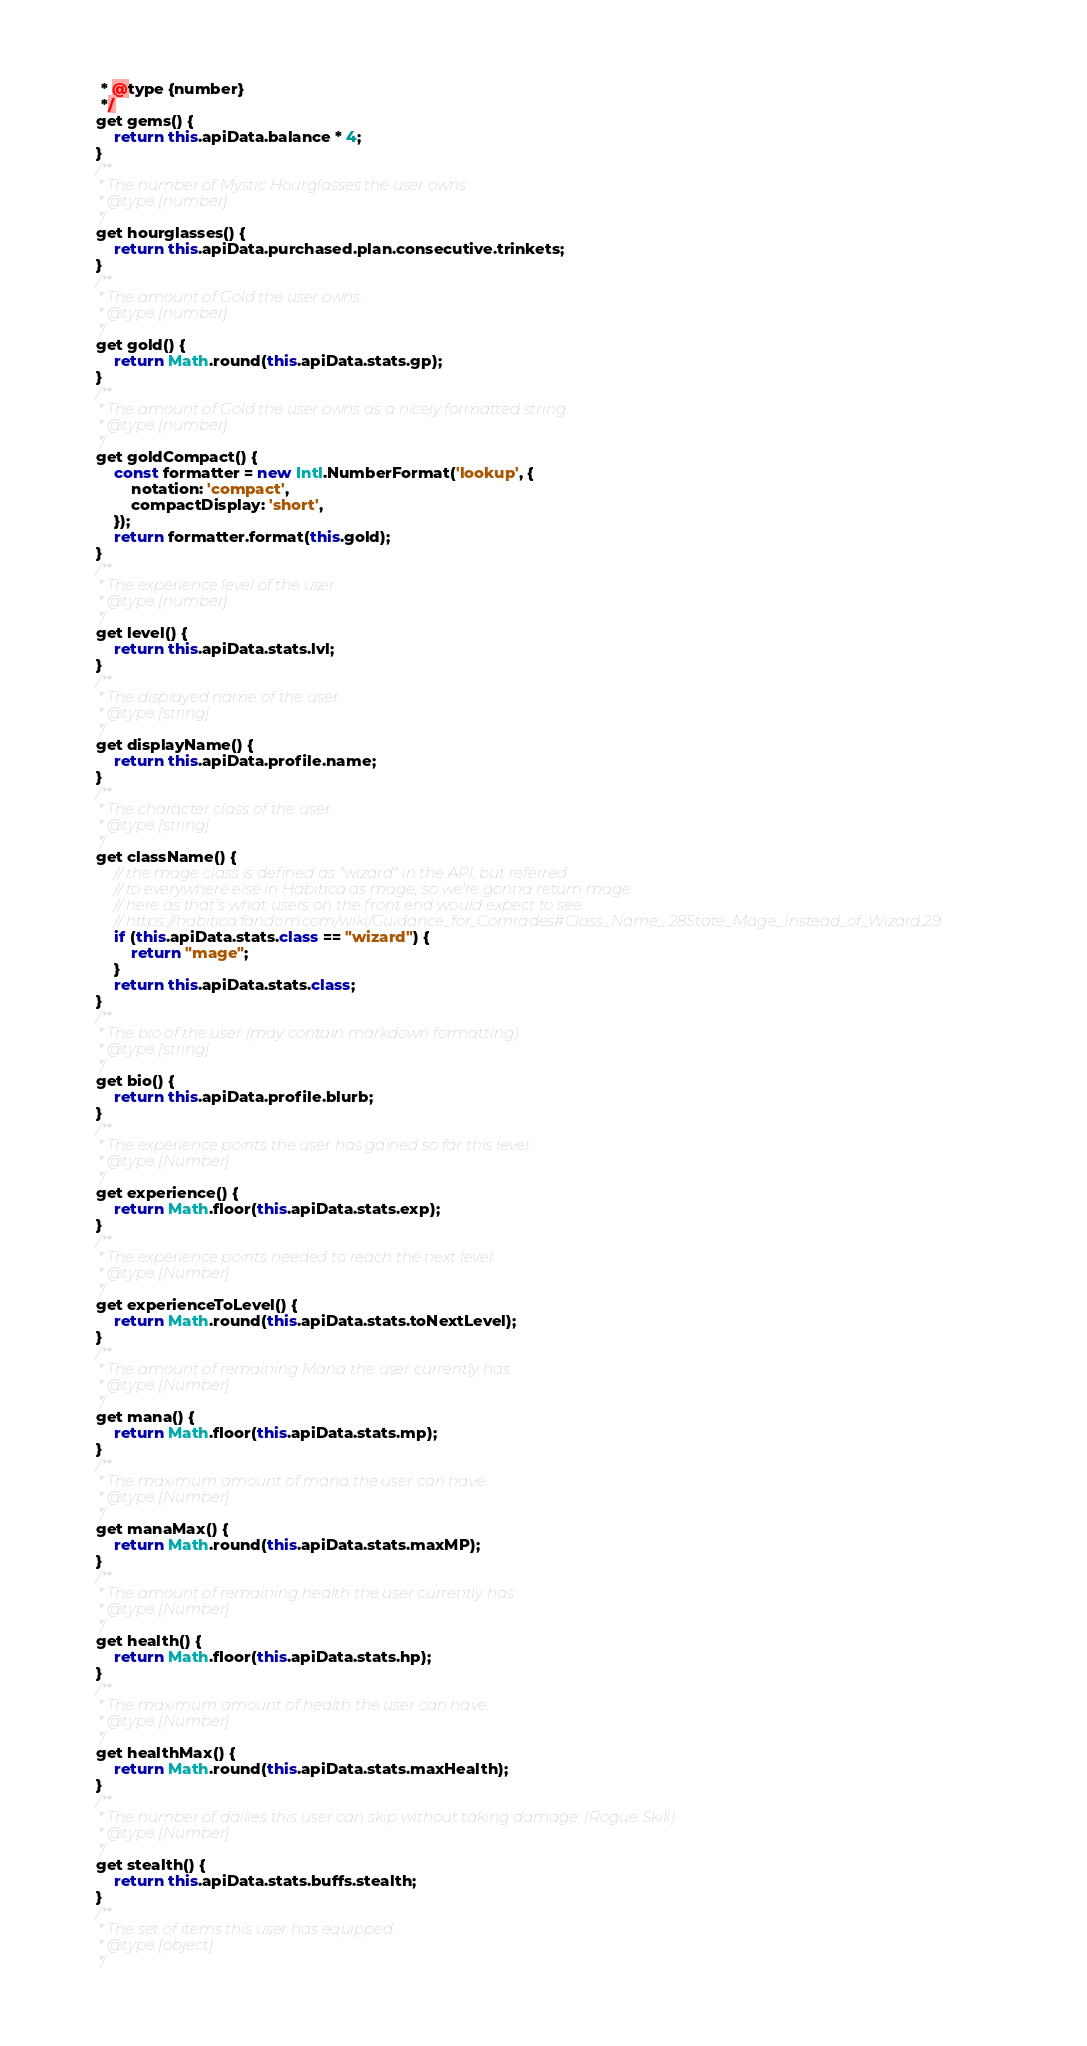<code> <loc_0><loc_0><loc_500><loc_500><_JavaScript_>	 * @type {number}
	 */
	get gems() {
		return this.apiData.balance * 4;
	}
	/**
	 * The number of Mystic Hourglasses the user owns.
	 * @type {number}
	 */
	get hourglasses() {
		return this.apiData.purchased.plan.consecutive.trinkets;
	}
	/**
	 * The amount of Gold the user owns.
	 * @type {number}
	 */
	get gold() {
		return Math.round(this.apiData.stats.gp);
	}
	/**
	 * The amount of Gold the user owns as a nicely formatted string.
	 * @type {number}
	 */
	get goldCompact() {
		const formatter = new Intl.NumberFormat('lookup', {
			notation: 'compact',
			compactDisplay: 'short',
		});
		return formatter.format(this.gold);
	}
	/**
	 * The experience level of the user.
	 * @type {number}
	 */
	get level() {
		return this.apiData.stats.lvl;
	}
	/**
	 * The displayed name of the user.
	 * @type {string}
	 */
	get displayName() {
		return this.apiData.profile.name;
	}
	/**
	 * The character class of the user.
	 * @type {string}
	 */
	get className() {
		// the mage class is defined as "wizard" in the API, but referred
		// to everywhere else in Habitica as mage, so we're gonna return mage
		// here as that's what users on the front end would expect to see
		// https://habitica.fandom.com/wiki/Guidance_for_Comrades#Class_Name_.28State_Mage_Instead_of_Wizard.29
		if (this.apiData.stats.class == "wizard") {
			return "mage";
		}
		return this.apiData.stats.class;
	}
	/**
	 * The bio of the user (may contain markdown formatting).
	 * @type {string}
	 */
	get bio() {
		return this.apiData.profile.blurb;
	}
	/**
	 * The experience points the user has gained so far this level.
	 * @type {Number}
	 */
	get experience() {
		return Math.floor(this.apiData.stats.exp);
	}
	/**
	 * The experience points needed to reach the next level.
	 * @type {Number}
	 */
	get experienceToLevel() {
		return Math.round(this.apiData.stats.toNextLevel);
	}
	/**
	 * The amount of remaining Mana the user currently has.
	 * @type {Number}
	 */
	get mana() {
		return Math.floor(this.apiData.stats.mp);
	}
	/**
	 * The maximum amount of mana the user can have.
	 * @type {Number}
	 */
	get manaMax() {
		return Math.round(this.apiData.stats.maxMP);
	}
	/**
	 * The amount of remaining health the user currently has.
	 * @type {Number}
	 */
	get health() {
		return Math.floor(this.apiData.stats.hp);
	}
	/**
	 * The maximum amount of health the user can have.
	 * @type {Number}
	 */
	get healthMax() {
		return Math.round(this.apiData.stats.maxHealth);
	}
	/**
	 * The number of dailies this user can skip without taking damage. (Rogue Skill)
	 * @type {Number}
	 */
	get stealth() {
		return this.apiData.stats.buffs.stealth;
	}
	/**
	 * The set of items this user has equipped.
	 * @type {object}
	 */</code> 